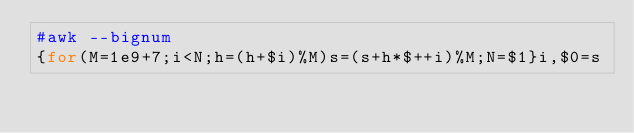<code> <loc_0><loc_0><loc_500><loc_500><_Awk_>#awk --bignum
{for(M=1e9+7;i<N;h=(h+$i)%M)s=(s+h*$++i)%M;N=$1}i,$0=s</code> 